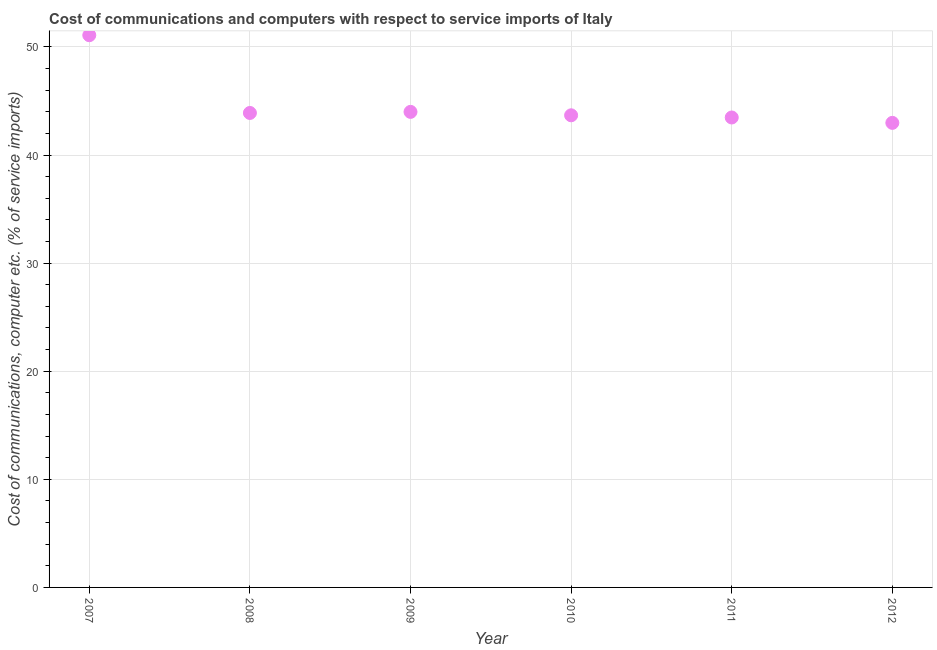What is the cost of communications and computer in 2011?
Provide a succinct answer. 43.47. Across all years, what is the maximum cost of communications and computer?
Offer a very short reply. 51.08. Across all years, what is the minimum cost of communications and computer?
Offer a very short reply. 42.98. In which year was the cost of communications and computer maximum?
Offer a very short reply. 2007. In which year was the cost of communications and computer minimum?
Your answer should be compact. 2012. What is the sum of the cost of communications and computer?
Provide a succinct answer. 269.09. What is the difference between the cost of communications and computer in 2008 and 2010?
Your answer should be very brief. 0.22. What is the average cost of communications and computer per year?
Your answer should be compact. 44.85. What is the median cost of communications and computer?
Give a very brief answer. 43.78. In how many years, is the cost of communications and computer greater than 16 %?
Ensure brevity in your answer.  6. What is the ratio of the cost of communications and computer in 2008 to that in 2009?
Offer a very short reply. 1. Is the cost of communications and computer in 2009 less than that in 2012?
Keep it short and to the point. No. What is the difference between the highest and the second highest cost of communications and computer?
Keep it short and to the point. 7.09. Is the sum of the cost of communications and computer in 2009 and 2010 greater than the maximum cost of communications and computer across all years?
Your response must be concise. Yes. What is the difference between the highest and the lowest cost of communications and computer?
Provide a short and direct response. 8.11. Does the cost of communications and computer monotonically increase over the years?
Offer a terse response. No. How many years are there in the graph?
Offer a terse response. 6. What is the difference between two consecutive major ticks on the Y-axis?
Your answer should be compact. 10. Does the graph contain any zero values?
Provide a short and direct response. No. Does the graph contain grids?
Ensure brevity in your answer.  Yes. What is the title of the graph?
Provide a short and direct response. Cost of communications and computers with respect to service imports of Italy. What is the label or title of the Y-axis?
Your response must be concise. Cost of communications, computer etc. (% of service imports). What is the Cost of communications, computer etc. (% of service imports) in 2007?
Your answer should be very brief. 51.08. What is the Cost of communications, computer etc. (% of service imports) in 2008?
Keep it short and to the point. 43.89. What is the Cost of communications, computer etc. (% of service imports) in 2009?
Provide a short and direct response. 43.99. What is the Cost of communications, computer etc. (% of service imports) in 2010?
Your response must be concise. 43.68. What is the Cost of communications, computer etc. (% of service imports) in 2011?
Offer a terse response. 43.47. What is the Cost of communications, computer etc. (% of service imports) in 2012?
Provide a succinct answer. 42.98. What is the difference between the Cost of communications, computer etc. (% of service imports) in 2007 and 2008?
Give a very brief answer. 7.19. What is the difference between the Cost of communications, computer etc. (% of service imports) in 2007 and 2009?
Make the answer very short. 7.09. What is the difference between the Cost of communications, computer etc. (% of service imports) in 2007 and 2010?
Offer a terse response. 7.41. What is the difference between the Cost of communications, computer etc. (% of service imports) in 2007 and 2011?
Keep it short and to the point. 7.61. What is the difference between the Cost of communications, computer etc. (% of service imports) in 2007 and 2012?
Make the answer very short. 8.11. What is the difference between the Cost of communications, computer etc. (% of service imports) in 2008 and 2009?
Offer a terse response. -0.1. What is the difference between the Cost of communications, computer etc. (% of service imports) in 2008 and 2010?
Offer a very short reply. 0.22. What is the difference between the Cost of communications, computer etc. (% of service imports) in 2008 and 2011?
Give a very brief answer. 0.42. What is the difference between the Cost of communications, computer etc. (% of service imports) in 2008 and 2012?
Give a very brief answer. 0.92. What is the difference between the Cost of communications, computer etc. (% of service imports) in 2009 and 2010?
Ensure brevity in your answer.  0.32. What is the difference between the Cost of communications, computer etc. (% of service imports) in 2009 and 2011?
Make the answer very short. 0.52. What is the difference between the Cost of communications, computer etc. (% of service imports) in 2009 and 2012?
Provide a short and direct response. 1.02. What is the difference between the Cost of communications, computer etc. (% of service imports) in 2010 and 2011?
Provide a succinct answer. 0.2. What is the difference between the Cost of communications, computer etc. (% of service imports) in 2010 and 2012?
Provide a succinct answer. 0.7. What is the difference between the Cost of communications, computer etc. (% of service imports) in 2011 and 2012?
Your answer should be compact. 0.5. What is the ratio of the Cost of communications, computer etc. (% of service imports) in 2007 to that in 2008?
Provide a short and direct response. 1.16. What is the ratio of the Cost of communications, computer etc. (% of service imports) in 2007 to that in 2009?
Your answer should be compact. 1.16. What is the ratio of the Cost of communications, computer etc. (% of service imports) in 2007 to that in 2010?
Keep it short and to the point. 1.17. What is the ratio of the Cost of communications, computer etc. (% of service imports) in 2007 to that in 2011?
Your answer should be very brief. 1.18. What is the ratio of the Cost of communications, computer etc. (% of service imports) in 2007 to that in 2012?
Give a very brief answer. 1.19. What is the ratio of the Cost of communications, computer etc. (% of service imports) in 2008 to that in 2012?
Provide a succinct answer. 1.02. What is the ratio of the Cost of communications, computer etc. (% of service imports) in 2009 to that in 2010?
Provide a succinct answer. 1.01. What is the ratio of the Cost of communications, computer etc. (% of service imports) in 2010 to that in 2011?
Make the answer very short. 1. What is the ratio of the Cost of communications, computer etc. (% of service imports) in 2010 to that in 2012?
Ensure brevity in your answer.  1.02. What is the ratio of the Cost of communications, computer etc. (% of service imports) in 2011 to that in 2012?
Make the answer very short. 1.01. 